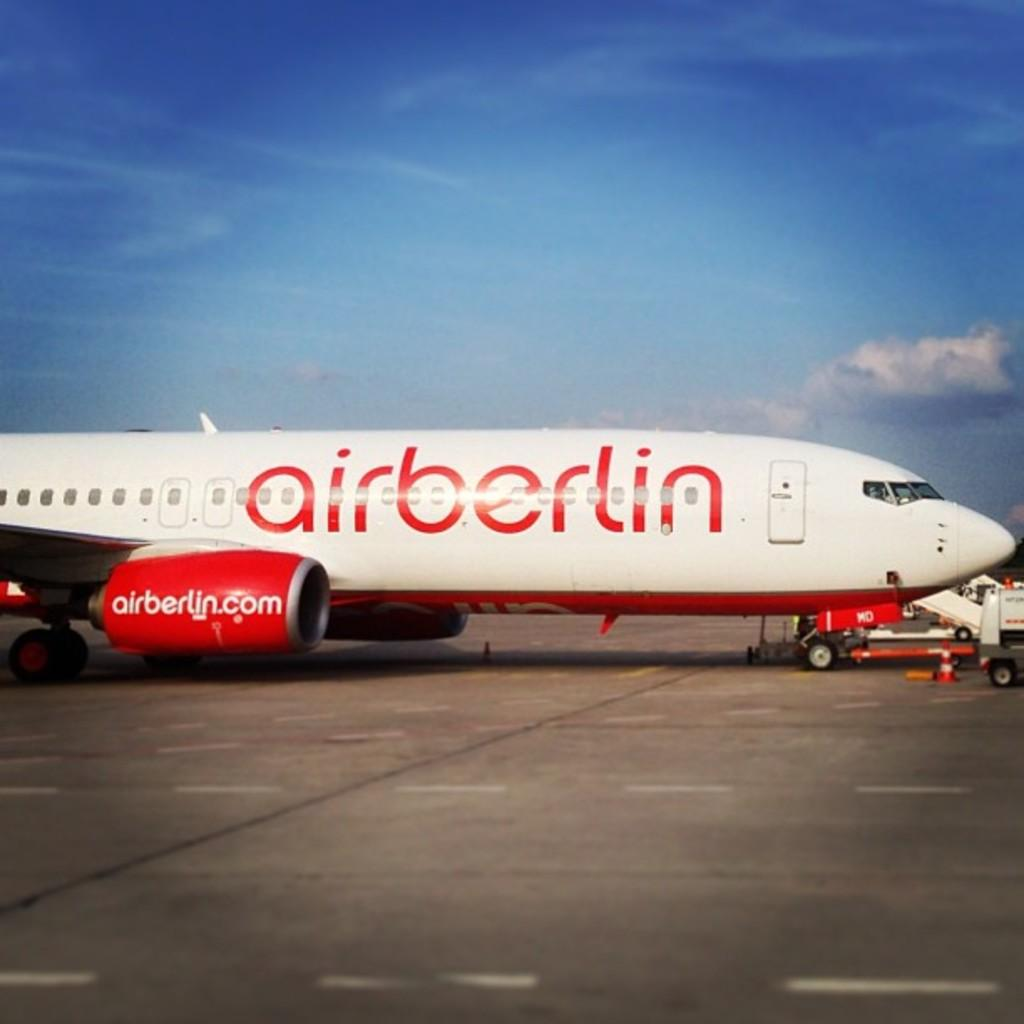<image>
Relay a brief, clear account of the picture shown. An Air Berlin fight at the airport terminal 